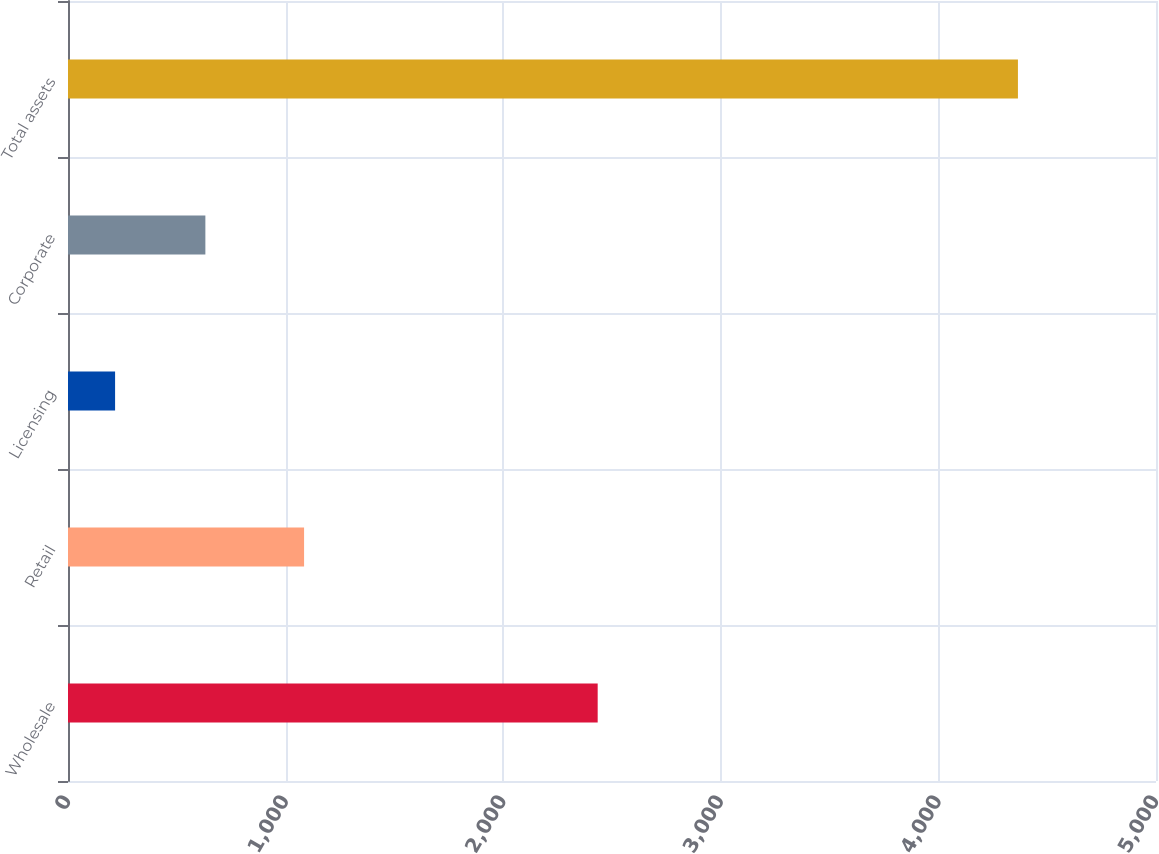<chart> <loc_0><loc_0><loc_500><loc_500><bar_chart><fcel>Wholesale<fcel>Retail<fcel>Licensing<fcel>Corporate<fcel>Total assets<nl><fcel>2434.2<fcel>1084.9<fcel>216.4<fcel>631.31<fcel>4365.5<nl></chart> 